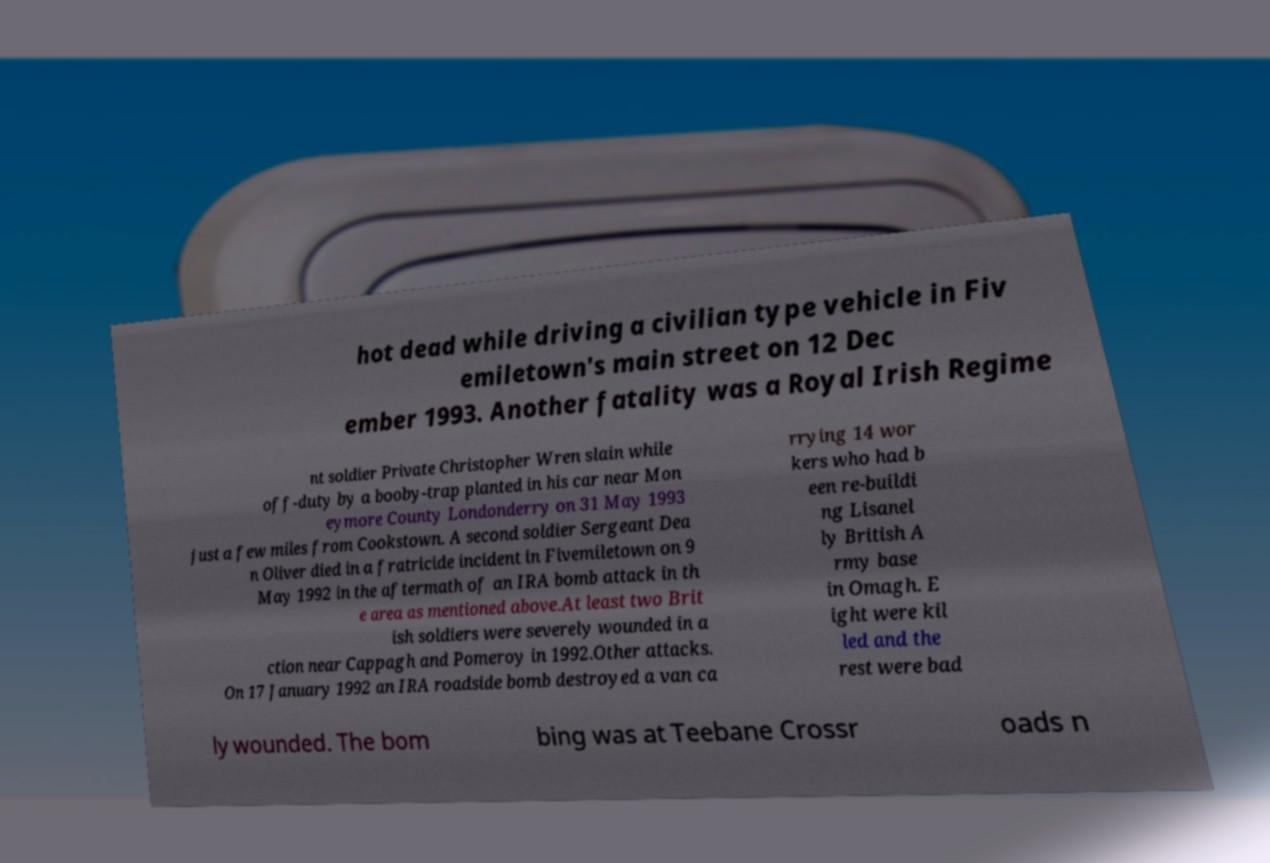Can you accurately transcribe the text from the provided image for me? hot dead while driving a civilian type vehicle in Fiv emiletown's main street on 12 Dec ember 1993. Another fatality was a Royal Irish Regime nt soldier Private Christopher Wren slain while off-duty by a booby-trap planted in his car near Mon eymore County Londonderry on 31 May 1993 just a few miles from Cookstown. A second soldier Sergeant Dea n Oliver died in a fratricide incident in Fivemiletown on 9 May 1992 in the aftermath of an IRA bomb attack in th e area as mentioned above.At least two Brit ish soldiers were severely wounded in a ction near Cappagh and Pomeroy in 1992.Other attacks. On 17 January 1992 an IRA roadside bomb destroyed a van ca rrying 14 wor kers who had b een re-buildi ng Lisanel ly British A rmy base in Omagh. E ight were kil led and the rest were bad ly wounded. The bom bing was at Teebane Crossr oads n 